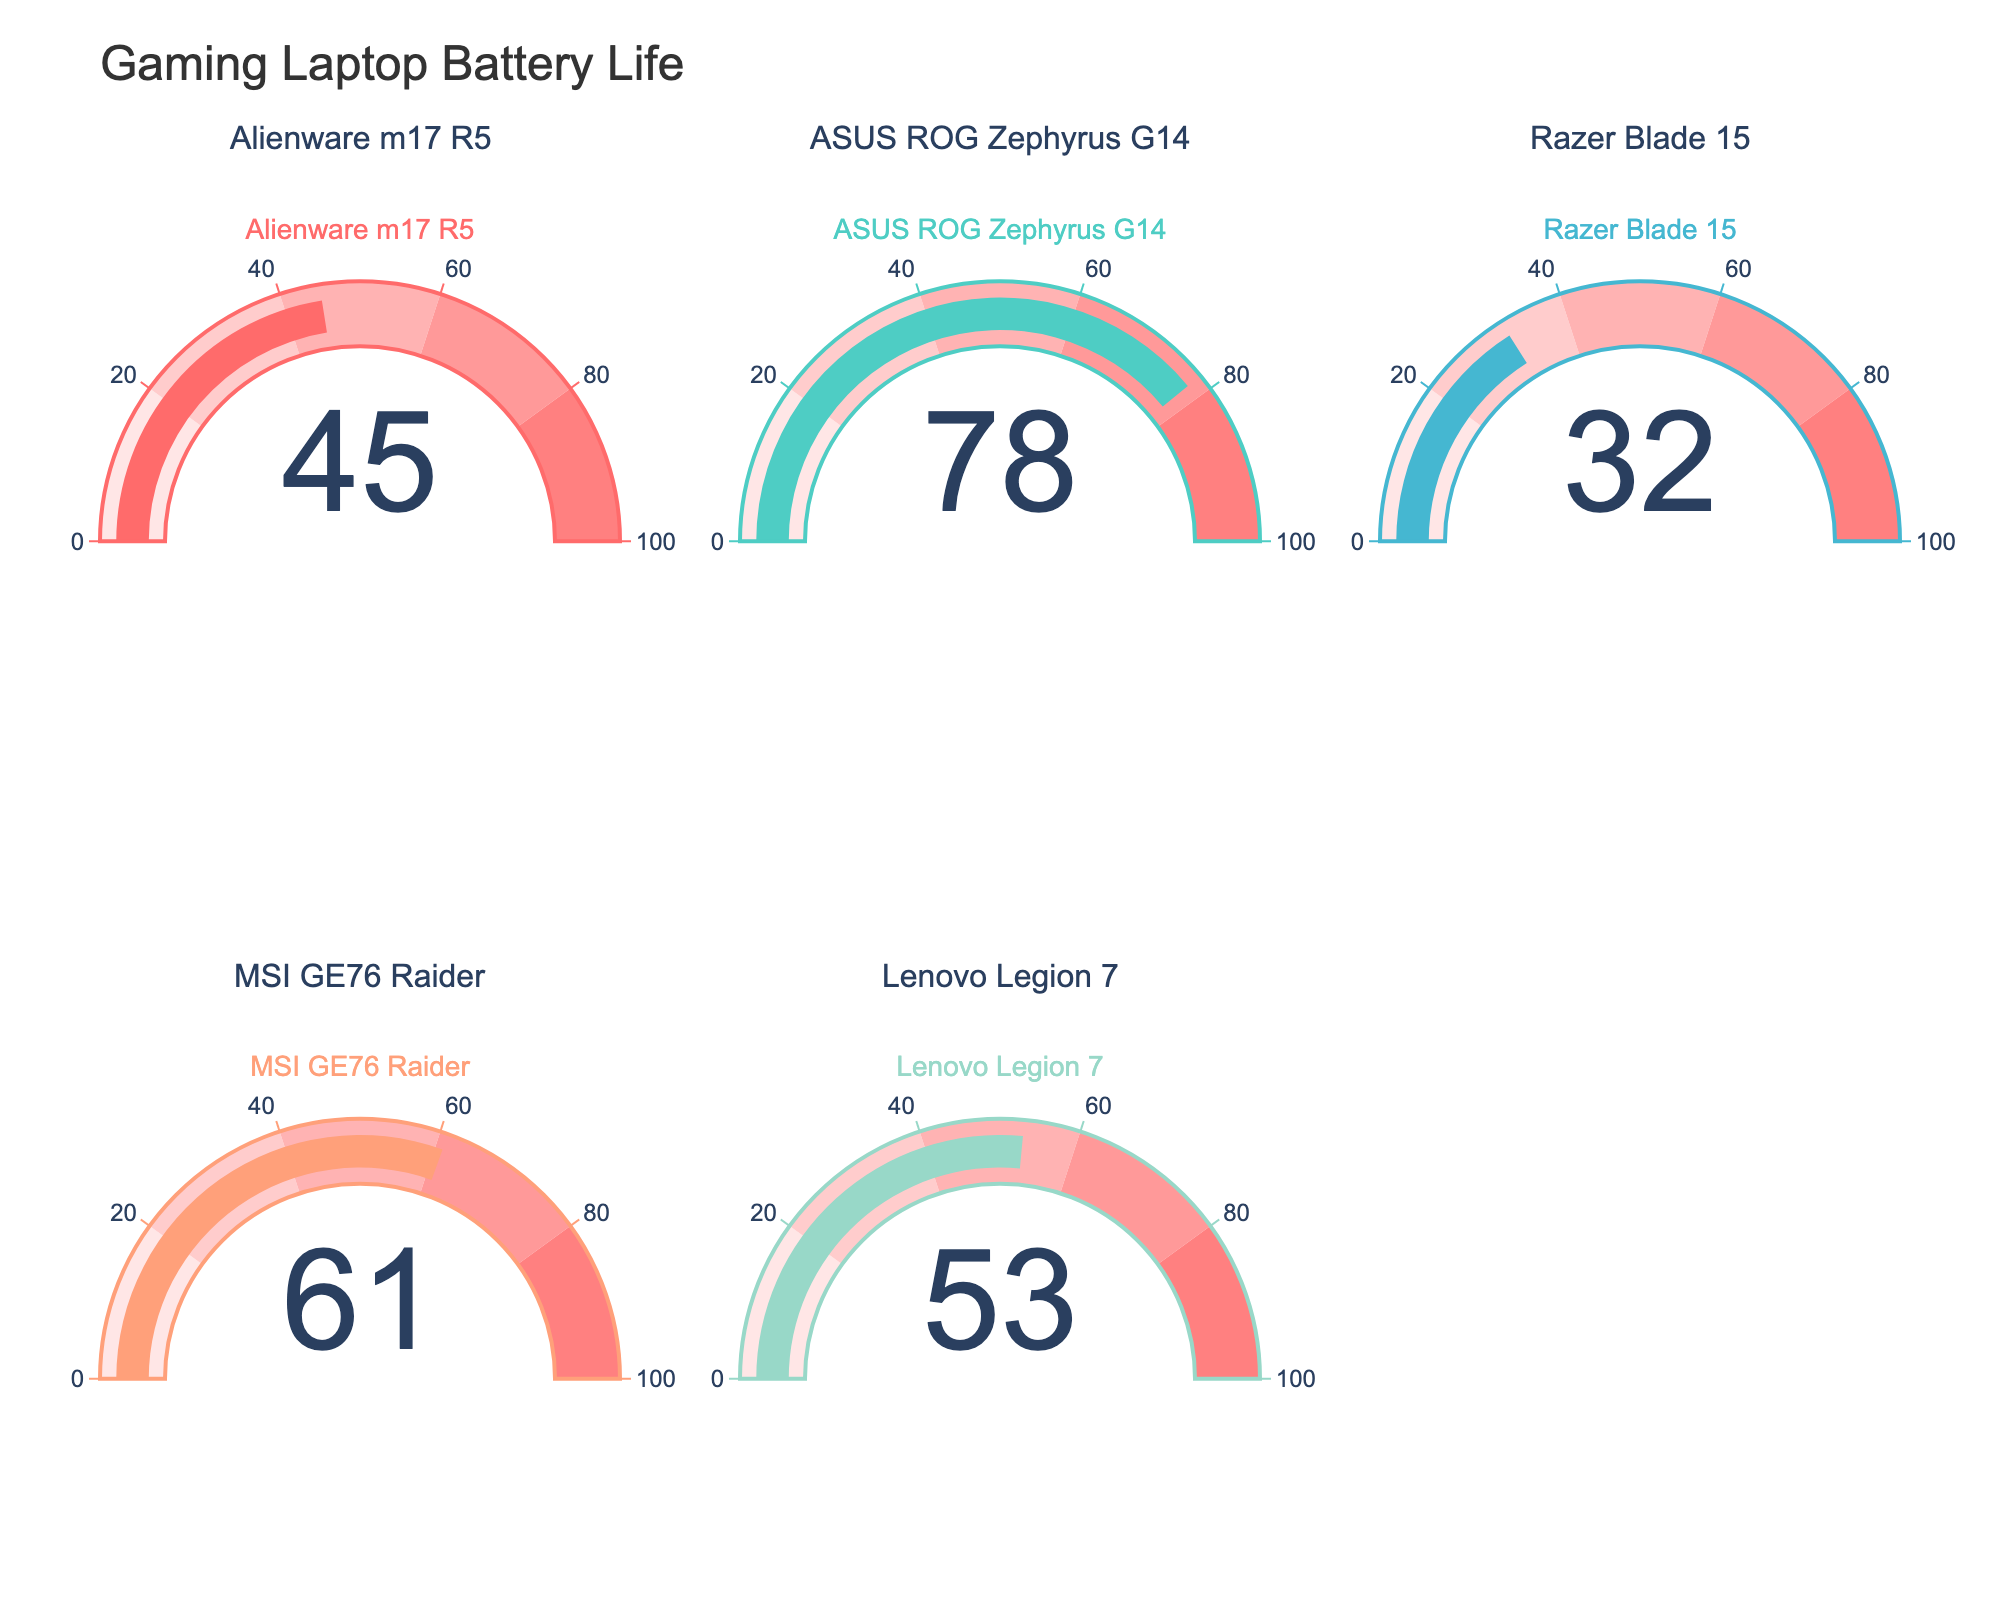What's the title of the figure? The title of the figure is generally located at the top and describes the overall content.
Answer: Gaming Laptop Battery Life How many gaming laptops are shown in the figure? Count the number of gauge charts, each representing a gaming laptop model.
Answer: 5 Which gaming laptop has the highest battery percentage remaining? Identify the gauge chart with the highest displayed number.
Answer: ASUS ROG Zephyrus G14 Which gaming laptop has the lowest battery percentage remaining? Identify the gauge chart with the lowest displayed number.
Answer: Razer Blade 15 What's the battery percentage of Lenovo Legion 7? Locate the gauge chart for Lenovo Legion 7 and note the number displayed.
Answer: 53 What's the average battery percentage of all the gaming laptops? Sum all the battery percentages and divide by the number of laptops: (45 + 78 + 32 + 61 + 53) / 5 = 53.8.
Answer: 53.8 Which gaming laptop has a battery percentage more than 70%? Identify the gauge charts displaying numbers greater than 70.
Answer: ASUS ROG Zephyrus G14 What's the range of battery percentages shown in the figure? Subtract the smallest battery percentage from the largest one: 78 - 32 = 46.
Answer: 46 How many laptops have a battery percentage above 50%? Count the gauge charts displaying numbers greater than 50.
Answer: 3 What is the total sum of the battery percentages for Alienware m17 R5 and MSI GE76 Raider? Add the battery percentages of Alienware m17 R5 and MSI GE76 Raider: 45 + 61 = 106.
Answer: 106 